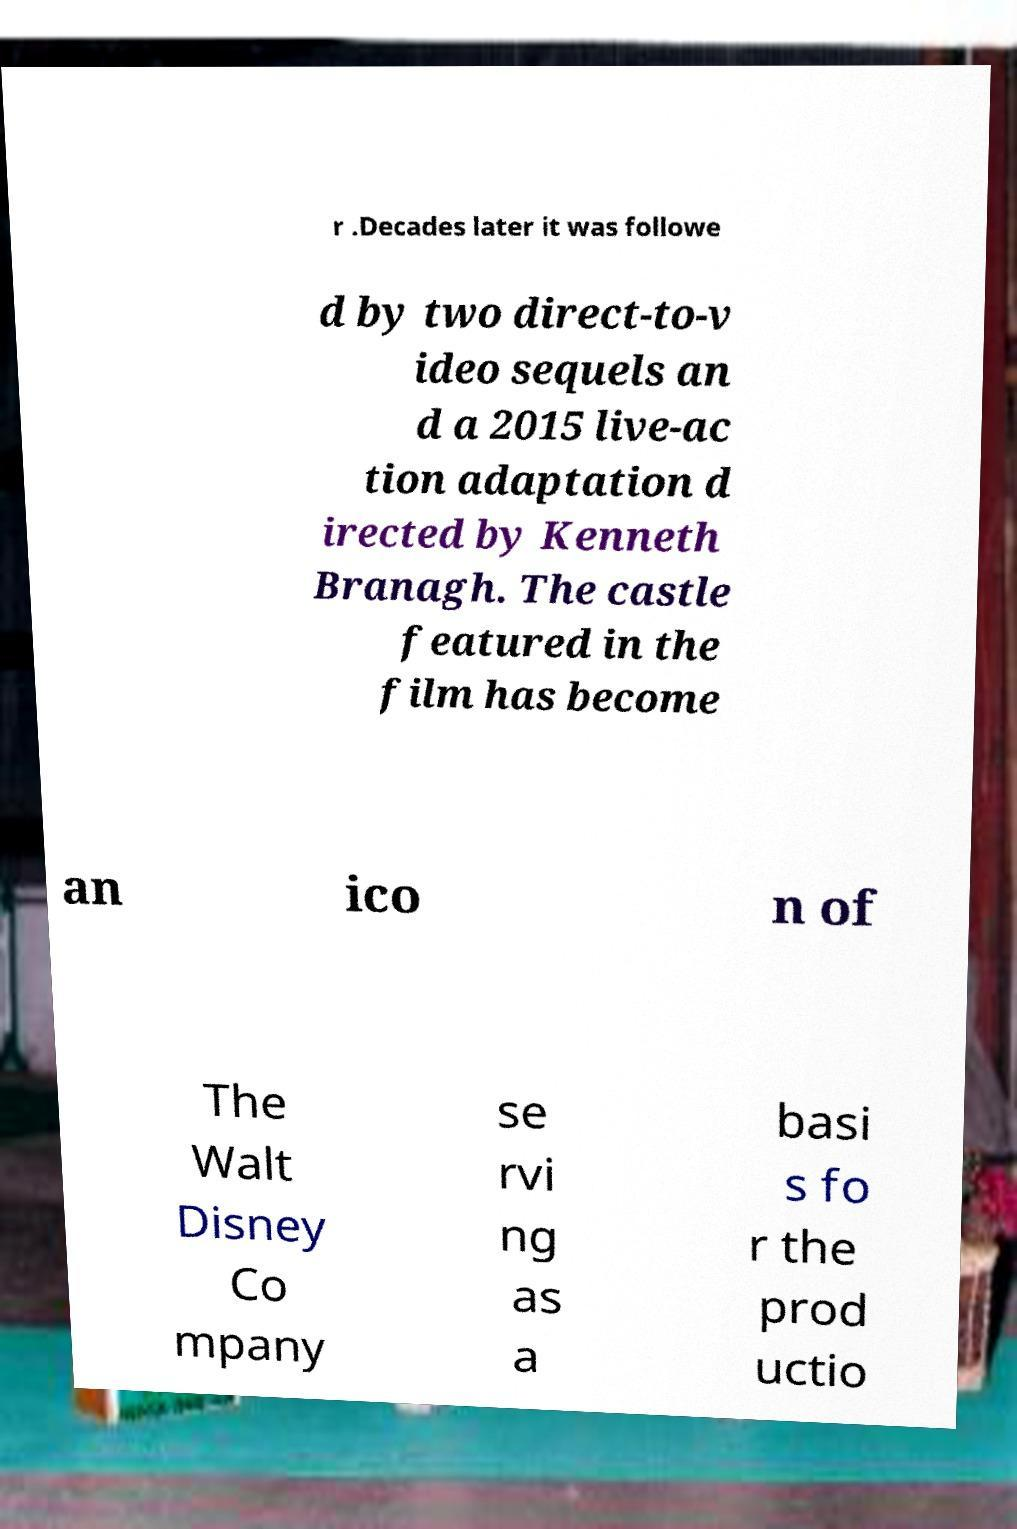Can you accurately transcribe the text from the provided image for me? r .Decades later it was followe d by two direct-to-v ideo sequels an d a 2015 live-ac tion adaptation d irected by Kenneth Branagh. The castle featured in the film has become an ico n of The Walt Disney Co mpany se rvi ng as a basi s fo r the prod uctio 